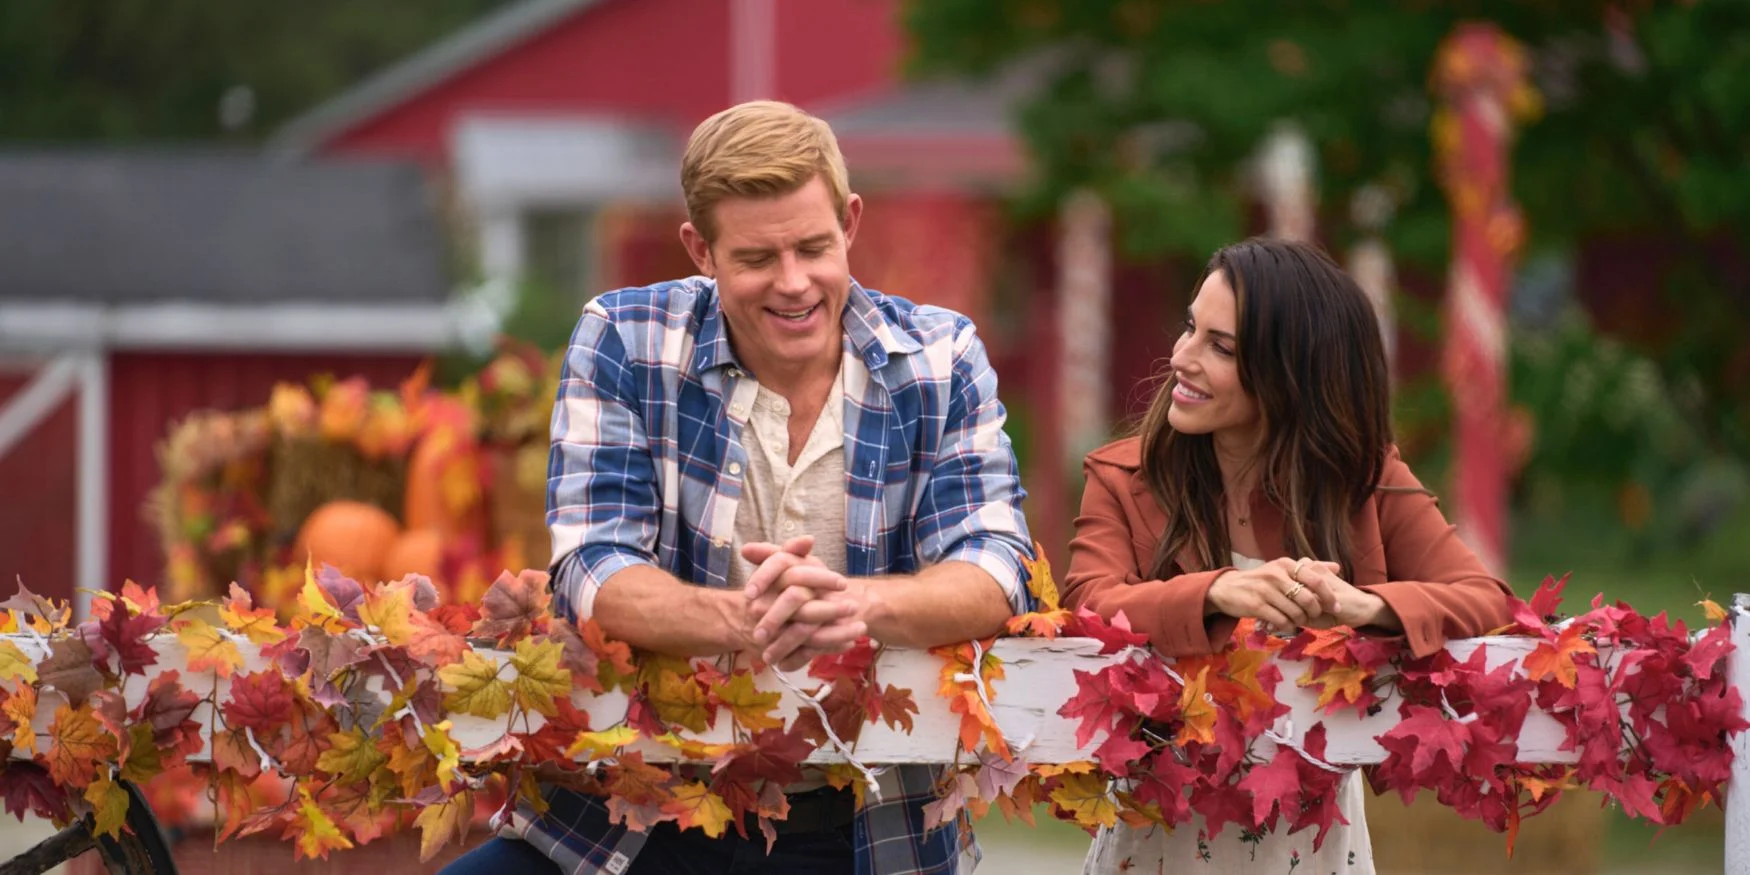Describe the setting of the image in detail. The setting of the image is a vibrant, idyllic autumn scene, characterized by a rich array of fall colors. The backdrop features a charming, rustic red barn, adding to the cozy farm-like atmosphere. Vibrant autumn leaves in shades of red, orange, and yellow adorn a white fence in the foreground, creating a visually appealing contrast. To the left, pumpkins are scattered around, contributing to the harvest-time theme. The overall ambiance is warm and inviting, epitomizing the essence of fall. 